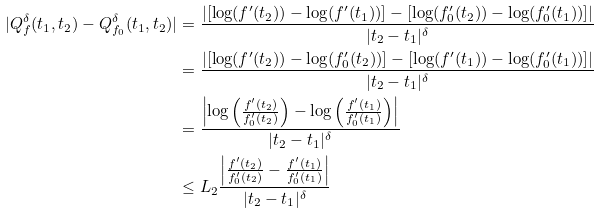Convert formula to latex. <formula><loc_0><loc_0><loc_500><loc_500>| Q _ { f } ^ { \delta } ( t _ { 1 } , t _ { 2 } ) - Q _ { f _ { 0 } } ^ { \delta } ( t _ { 1 } , t _ { 2 } ) | & = \frac { | [ \log ( f ^ { \prime } ( t _ { 2 } ) ) - \log ( f ^ { \prime } ( t _ { 1 } ) ) ] - [ \log ( f ^ { \prime } _ { 0 } ( t _ { 2 } ) ) - \log ( f ^ { \prime } _ { 0 } ( t _ { 1 } ) ) ] | } { | t _ { 2 } - t _ { 1 } | ^ { \delta } } \\ & = \frac { | [ \log ( f ^ { \prime } ( t _ { 2 } ) ) - \log ( f ^ { \prime } _ { 0 } ( t _ { 2 } ) ) ] - [ \log ( f ^ { \prime } ( t _ { 1 } ) ) - \log ( f ^ { \prime } _ { 0 } ( t _ { 1 } ) ) ] | } { | t _ { 2 } - t _ { 1 } | ^ { \delta } } \\ & = \frac { \left | \log \left ( \frac { f ^ { \prime } ( t _ { 2 } ) } { f ^ { \prime } _ { 0 } ( t _ { 2 } ) } \right ) - \log \left ( \frac { f ^ { \prime } ( t _ { 1 } ) } { f ^ { \prime } _ { 0 } ( t _ { 1 } ) } \right ) \right | } { | t _ { 2 } - t _ { 1 } | ^ { \delta } } \\ & \leq L _ { 2 } \frac { \left | \frac { f ^ { \prime } ( t _ { 2 } ) } { f ^ { \prime } _ { 0 } ( t _ { 2 } ) } - \frac { f ^ { \prime } ( t _ { 1 } ) } { f ^ { \prime } _ { 0 } ( t _ { 1 } ) } \right | } { | t _ { 2 } - t _ { 1 } | ^ { \delta } }</formula> 